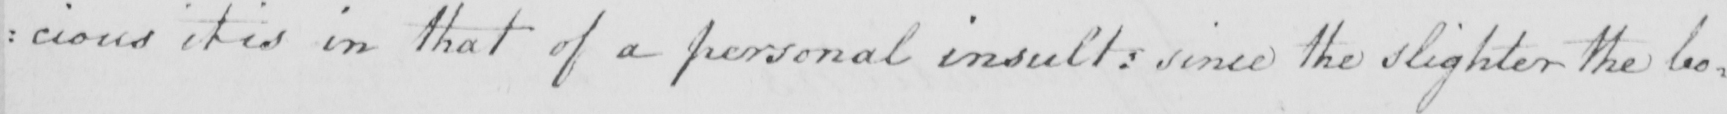What text is written in this handwritten line? : cious it is in that of a personal insult :  since the slighter the bo= 